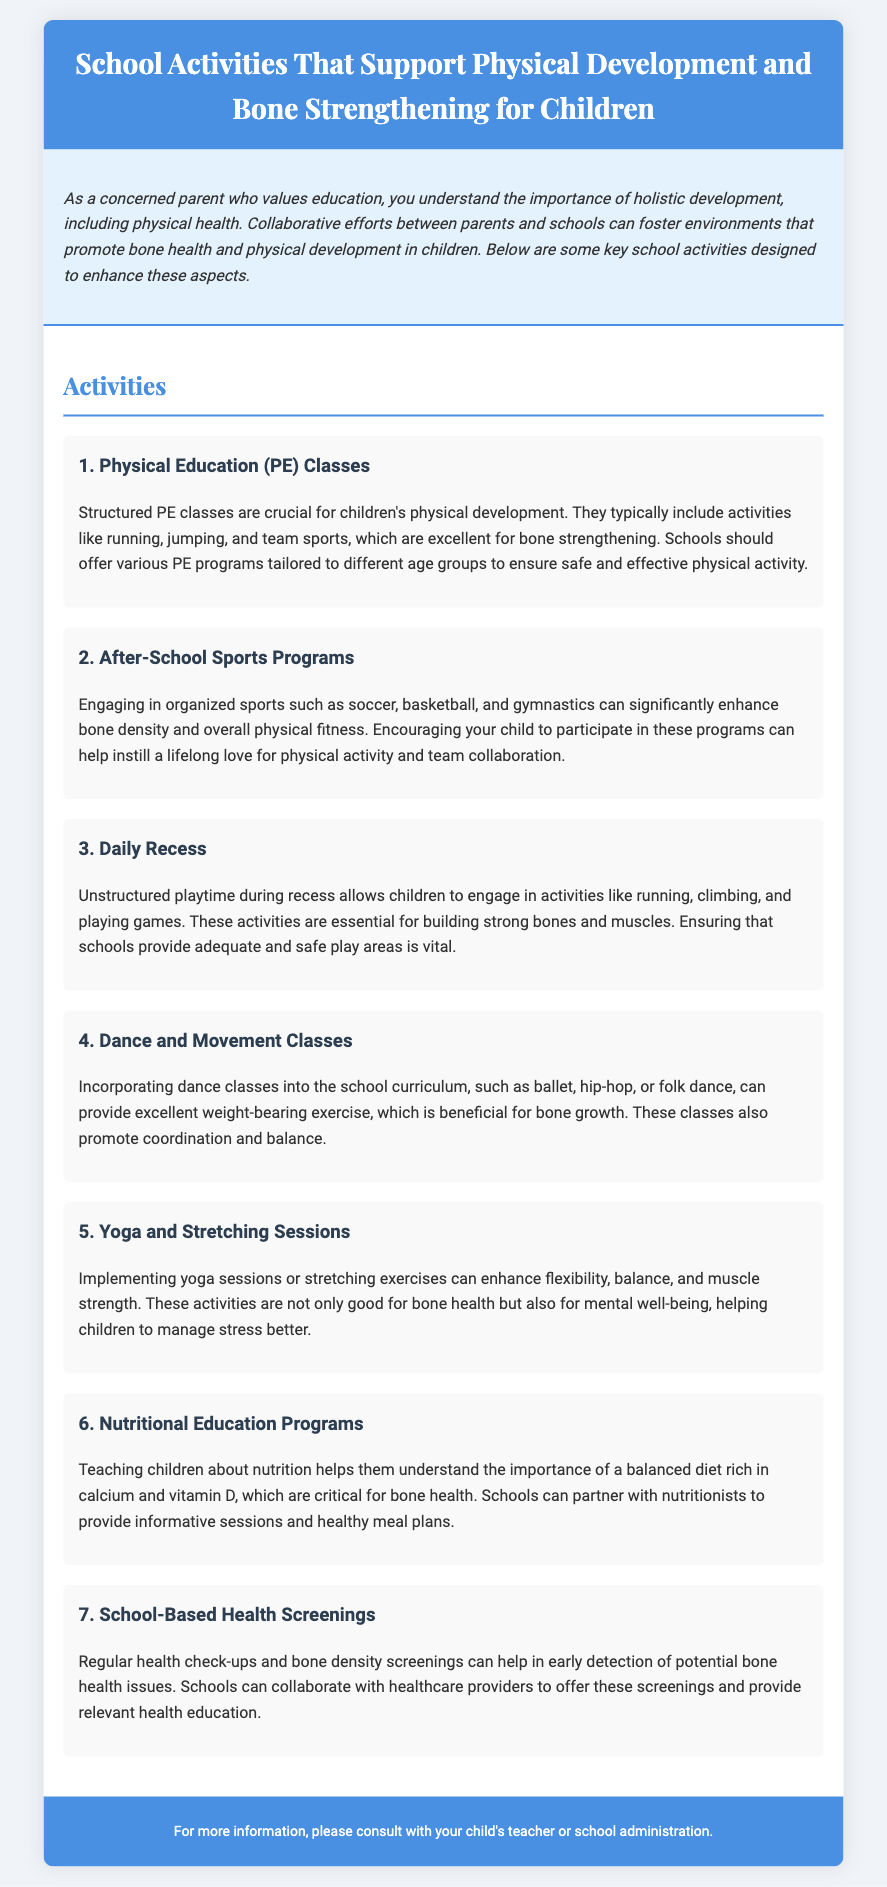What is the title of the document? The title can be found in the header section of the document.
Answer: School Activities That Support Physical Development and Bone Strengthening for Children How many activities are listed in the document? The number of activities can be counted from the content section.
Answer: 7 What type of exercise does the 'Dance and Movement Classes' activity focus on? This can be inferred from the description of the activity in the document.
Answer: Weight-bearing exercise Which vitamin is essential for bone health according to the document? The document mentions specific nutrients related to bone health in the nutritional education programs section.
Answer: Vitamin D What kind of classes are included in the fourth activity? The document specifies the types of classes in the description of the fourth activity.
Answer: Dance classes What is one benefit of Yoga and Stretching Sessions mentioned? The document provides specific benefits listed in the description of the activity.
Answer: Flexibility What is emphasized in the 'Nutritional Education Programs'? This can be inferred from the emphasis in the description of the activity.
Answer: Balanced diet rich in calcium What is the main purpose of the 'School-Based Health Screenings'? The document explains the purpose of this activity in the corresponding section.
Answer: Early detection of potential bone health issues 